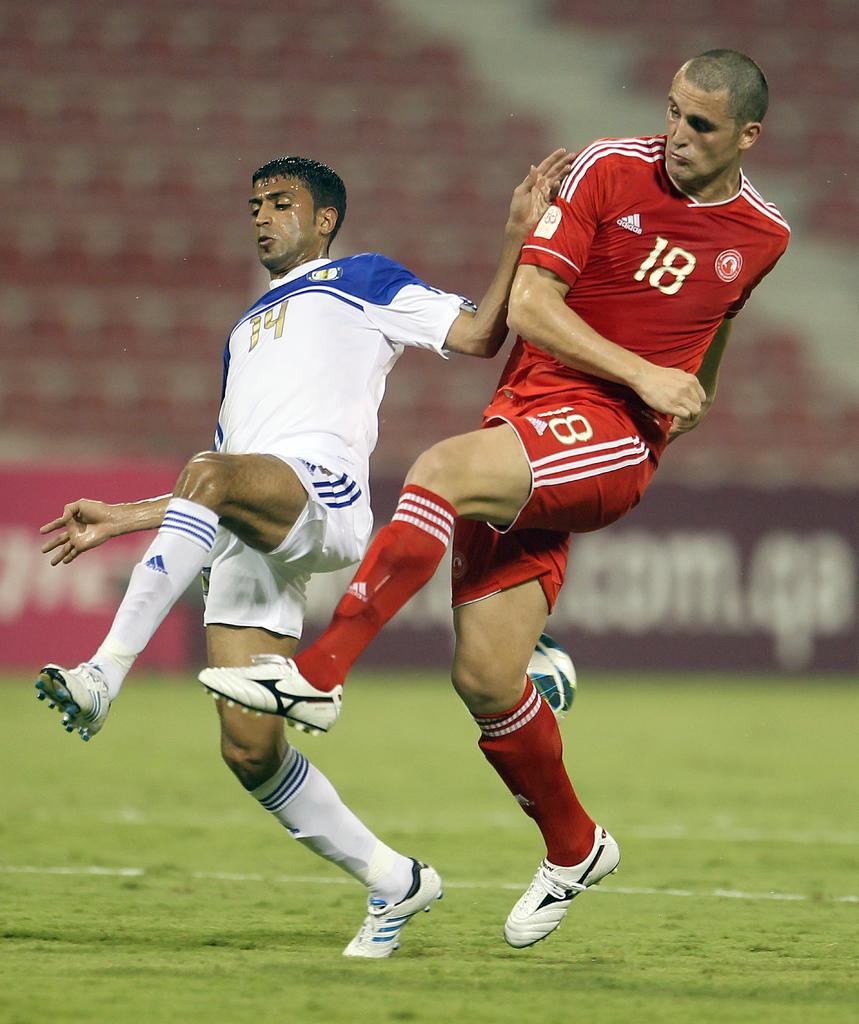<image>
Offer a succinct explanation of the picture presented. Players with the numbers 14 and 18 on their jerseys both have their legs lifted in the air. 